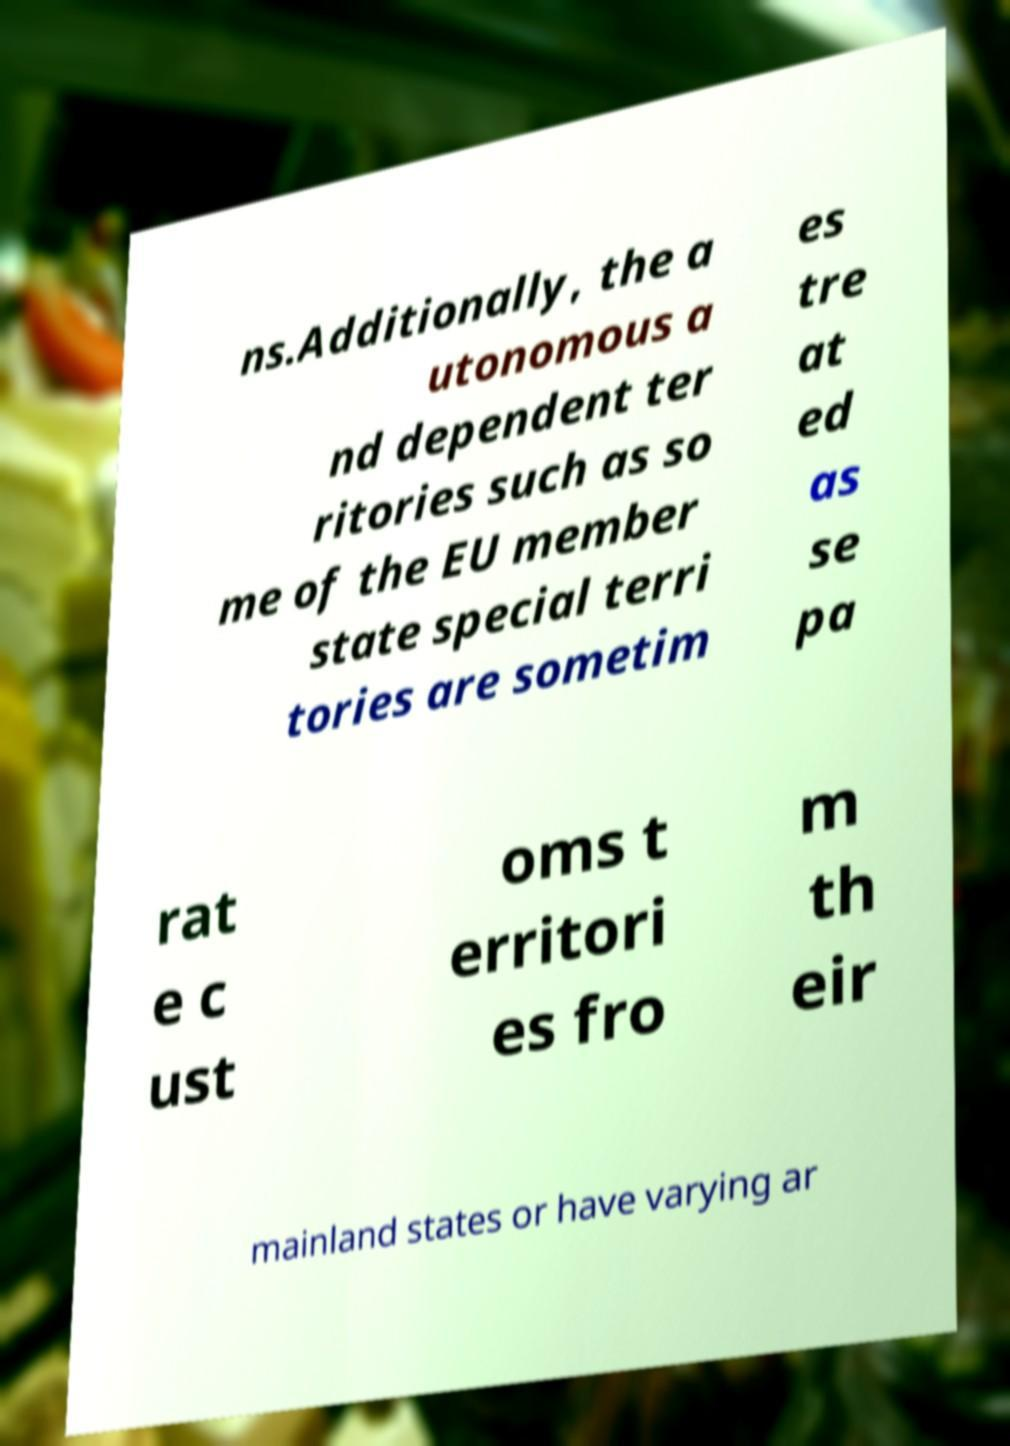Could you assist in decoding the text presented in this image and type it out clearly? ns.Additionally, the a utonomous a nd dependent ter ritories such as so me of the EU member state special terri tories are sometim es tre at ed as se pa rat e c ust oms t erritori es fro m th eir mainland states or have varying ar 